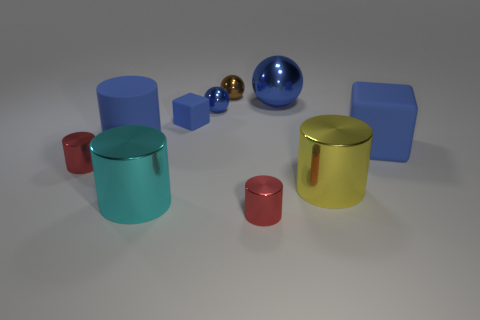Subtract all yellow cylinders. How many cylinders are left? 4 Subtract all red cubes. How many red cylinders are left? 2 Subtract all blue cylinders. How many cylinders are left? 4 Subtract 1 balls. How many balls are left? 2 Subtract all spheres. How many objects are left? 7 Subtract all gray cylinders. Subtract all blue spheres. How many cylinders are left? 5 Add 6 tiny balls. How many tiny balls exist? 8 Subtract 1 red cylinders. How many objects are left? 9 Subtract all large red cylinders. Subtract all yellow things. How many objects are left? 9 Add 4 big metal balls. How many big metal balls are left? 5 